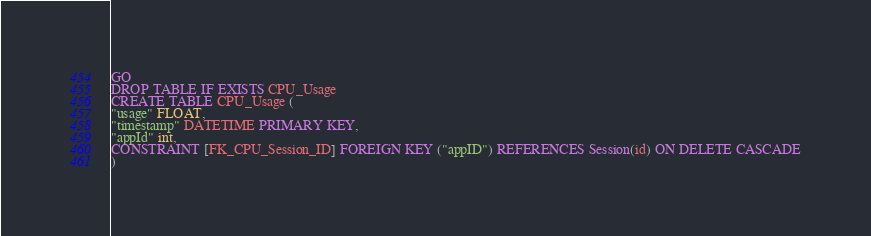Convert code to text. <code><loc_0><loc_0><loc_500><loc_500><_SQL_>GO
DROP TABLE IF EXISTS CPU_Usage
CREATE TABLE CPU_Usage (
"usage" FLOAT, 
"timestamp" DATETIME PRIMARY KEY,
"appId" int,
CONSTRAINT [FK_CPU_Session_ID] FOREIGN KEY ("appID") REFERENCES Session(id) ON DELETE CASCADE
)</code> 